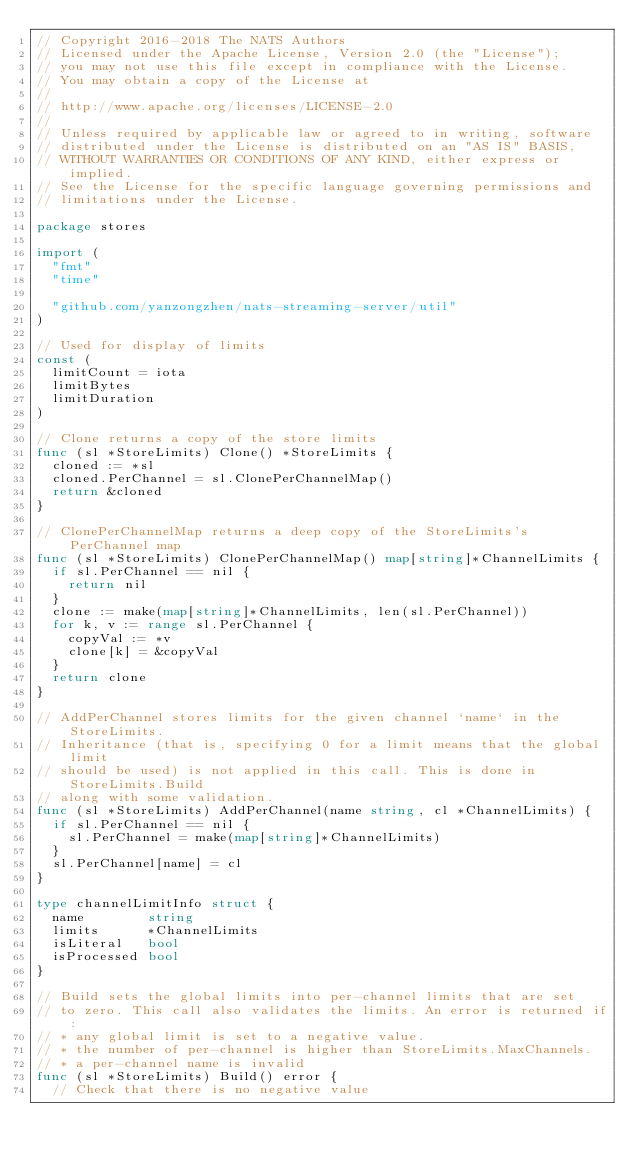<code> <loc_0><loc_0><loc_500><loc_500><_Go_>// Copyright 2016-2018 The NATS Authors
// Licensed under the Apache License, Version 2.0 (the "License");
// you may not use this file except in compliance with the License.
// You may obtain a copy of the License at
//
// http://www.apache.org/licenses/LICENSE-2.0
//
// Unless required by applicable law or agreed to in writing, software
// distributed under the License is distributed on an "AS IS" BASIS,
// WITHOUT WARRANTIES OR CONDITIONS OF ANY KIND, either express or implied.
// See the License for the specific language governing permissions and
// limitations under the License.

package stores

import (
	"fmt"
	"time"

	"github.com/yanzongzhen/nats-streaming-server/util"
)

// Used for display of limits
const (
	limitCount = iota
	limitBytes
	limitDuration
)

// Clone returns a copy of the store limits
func (sl *StoreLimits) Clone() *StoreLimits {
	cloned := *sl
	cloned.PerChannel = sl.ClonePerChannelMap()
	return &cloned
}

// ClonePerChannelMap returns a deep copy of the StoreLimits's PerChannel map
func (sl *StoreLimits) ClonePerChannelMap() map[string]*ChannelLimits {
	if sl.PerChannel == nil {
		return nil
	}
	clone := make(map[string]*ChannelLimits, len(sl.PerChannel))
	for k, v := range sl.PerChannel {
		copyVal := *v
		clone[k] = &copyVal
	}
	return clone
}

// AddPerChannel stores limits for the given channel `name` in the StoreLimits.
// Inheritance (that is, specifying 0 for a limit means that the global limit
// should be used) is not applied in this call. This is done in StoreLimits.Build
// along with some validation.
func (sl *StoreLimits) AddPerChannel(name string, cl *ChannelLimits) {
	if sl.PerChannel == nil {
		sl.PerChannel = make(map[string]*ChannelLimits)
	}
	sl.PerChannel[name] = cl
}

type channelLimitInfo struct {
	name        string
	limits      *ChannelLimits
	isLiteral   bool
	isProcessed bool
}

// Build sets the global limits into per-channel limits that are set
// to zero. This call also validates the limits. An error is returned if:
// * any global limit is set to a negative value.
// * the number of per-channel is higher than StoreLimits.MaxChannels.
// * a per-channel name is invalid
func (sl *StoreLimits) Build() error {
	// Check that there is no negative value</code> 